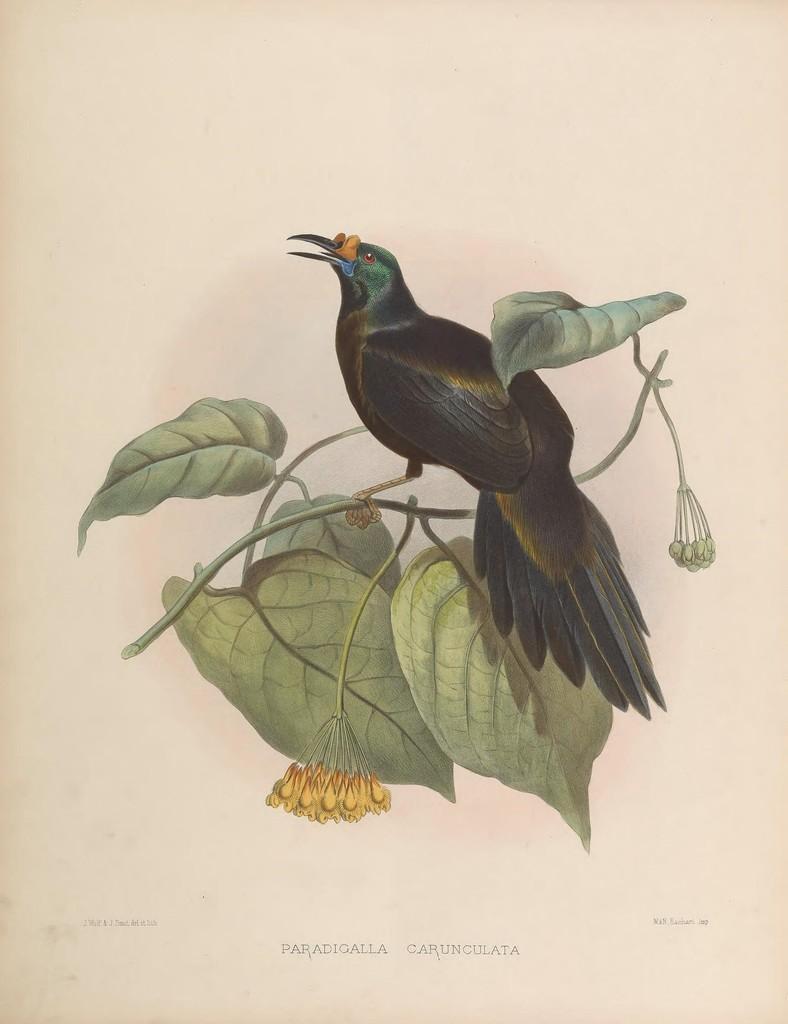How would you summarize this image in a sentence or two? In this image there is a painting of a bird standing on a branch. On the branch there are leaves and flowers. 